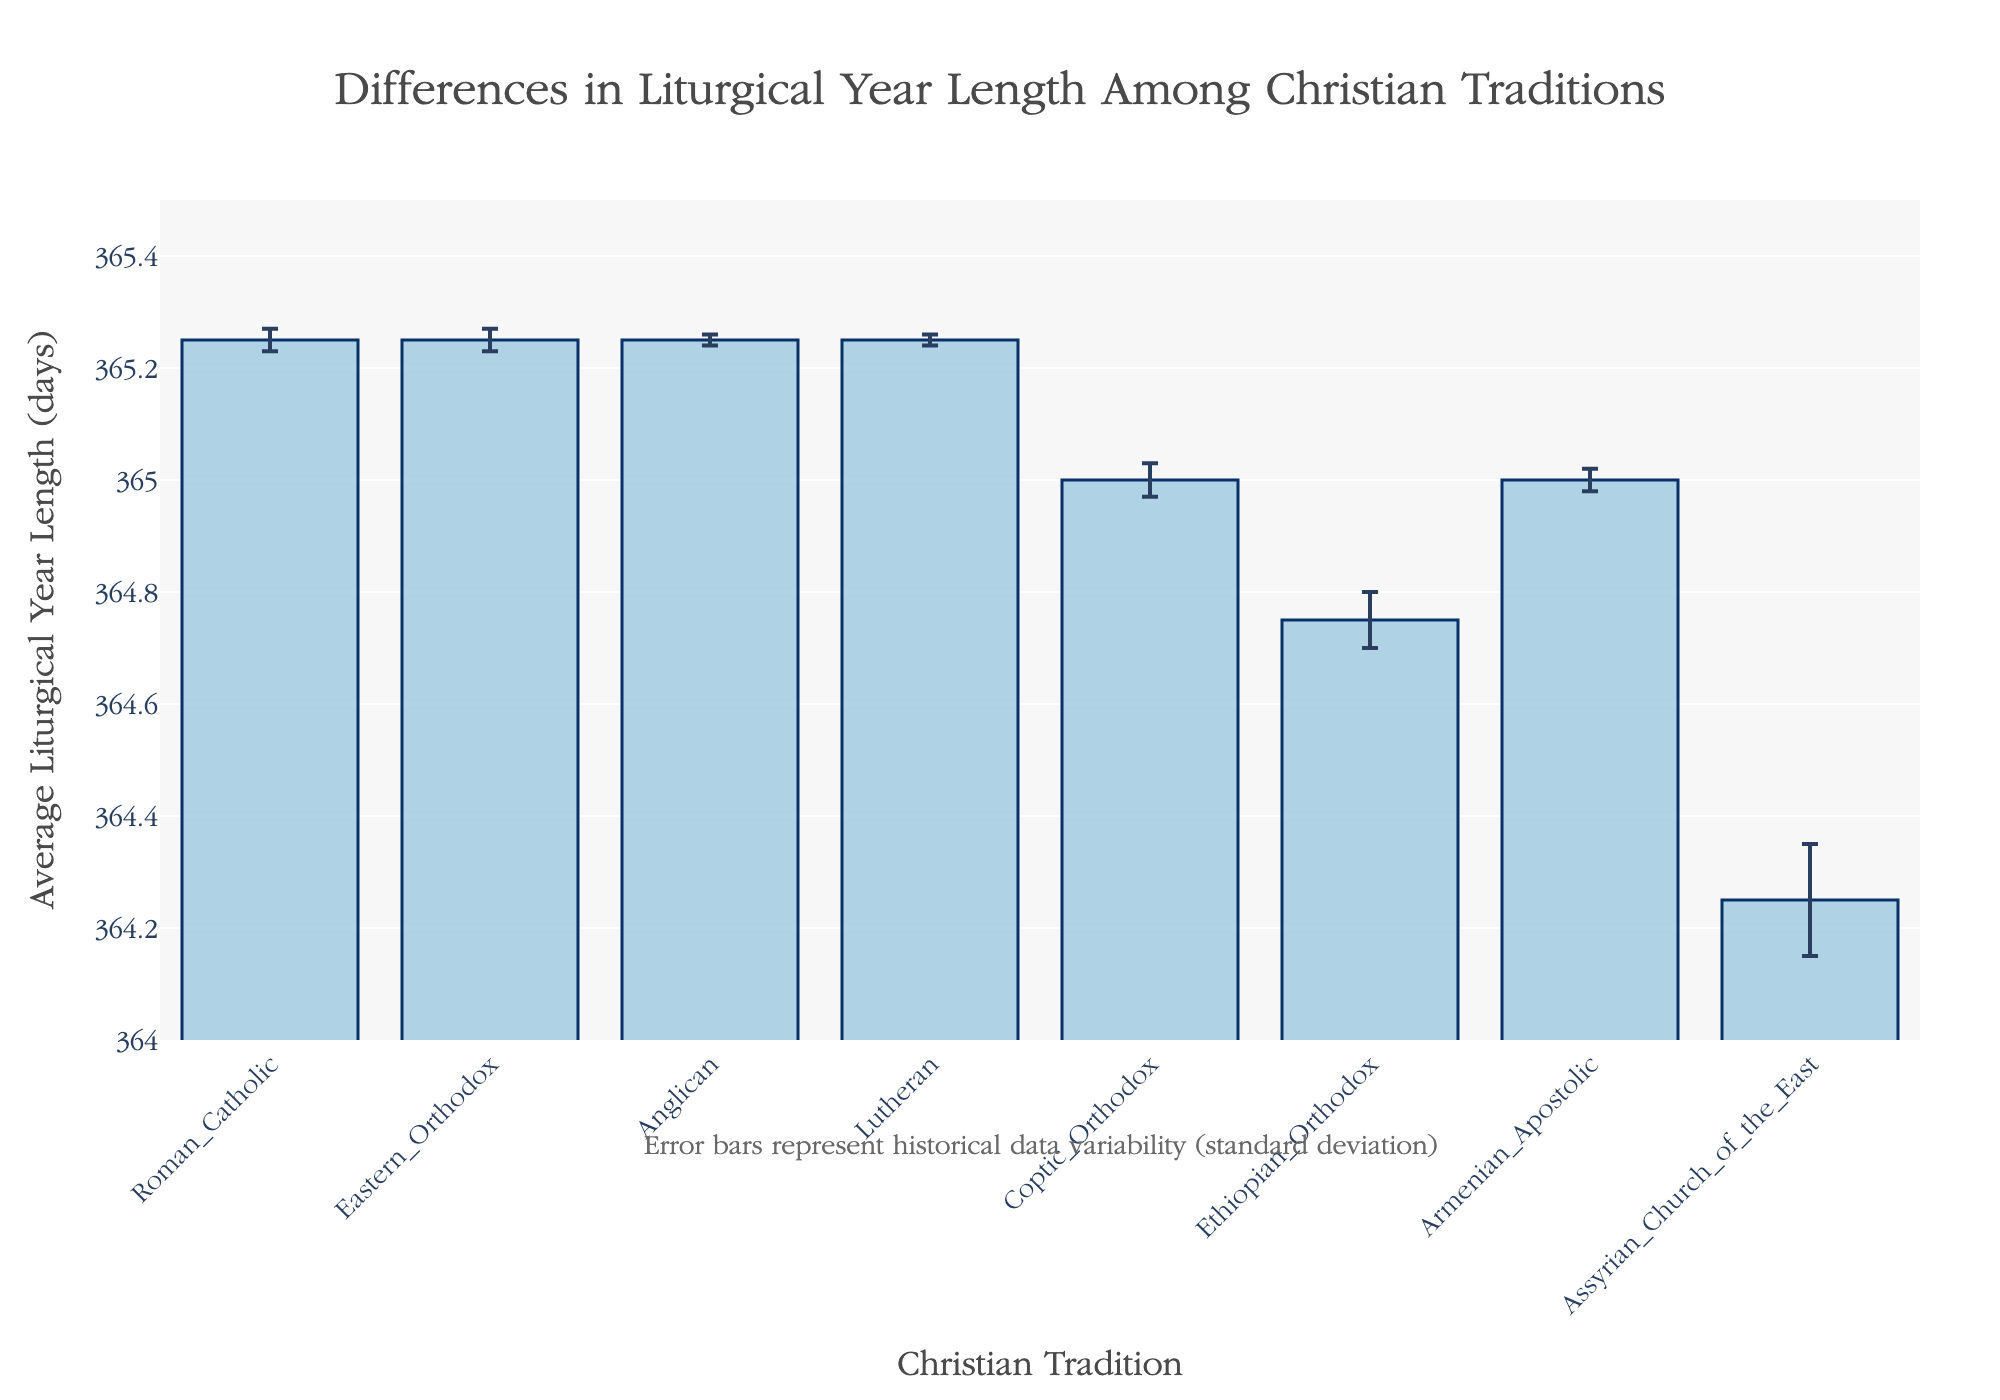What is the average length of the liturgical year for the Roman Catholic tradition? The figure shows the average liturgical year lengths on the y-axis, and the Roman Catholic tradition is one of the values on the x-axis. By locating Roman Catholic on the x-axis and checking the corresponding bar, we see 365.25 days.
Answer: 365.25 days Which tradition has the greatest variability in the length of its liturgical year? The variability is represented by the size of the error bars. The figure shows that the Assyrian Church of the East has the largest error bar, indicating the highest standard deviation.
Answer: Assyrian Church of the East How does the average liturgical year length of the Coptic Orthodox Church compare to the Roman Catholic Church? The Coptic Orthodox Church has an average liturgical year length of 365.00 days, while the Roman Catholic Church has an average of 365.25 days. The Roman Catholic year is 0.25 days longer.
Answer: Roman Catholic: 0.25 days longer What is the standard deviation in the liturgical year length for the Ethiopian Orthodox tradition? Standard deviation is indicated by the error bars. Following the Ethiopian Orthodox on the x-axis and checking the corresponding error bar value, we see it is 0.05 days.
Answer: 0.05 days Is the average liturgical year length of the Anglican tradition greater than 365 days? To answer this, we need to check whether the average point on the y-axis for the Anglican tradition exceeds 365 days. It is 365.25 days, which is greater than 365.
Answer: Yes Which traditions have the average liturgical year lengths less than 365 days? The figure shows that Ethiopian Orthodox (364.75 days) and Assyrian Church of the East (364.25 days) have average year lengths below 365 days.
Answer: Ethiopian Orthodox and Assyrian Church of the East How many traditions have an average liturgical year length exactly equal to 365.00 days? Checking the figure, we see that both Coptic Orthodox and Armenian Apostolic each have average liturgical year lengths of exactly 365.00 days.
Answer: 2 traditions Between Eastern Orthodox and Coptic Orthodox traditions, which has a smaller variability in liturgical year length? Variability is measured by the size of the error bars. The figure shows that Coptic Orthodox has a standard deviation of 0.03, whereas Eastern Orthodox has 0.02. Therefore, the Eastern Orthodox Church has smaller variability.
Answer: Eastern Orthodox What is the combined average liturgical year length of Anglican and Lutheran traditions? The figure shows that both Anglican and Lutheran churches have average year lengths of 365.25 days. Adding these together gives a combined average of 365.25 + 365.25 = 730.5 days.
Answer: 730.5 days What is the median average liturgical year length among all traditions shown? To find the median, we list the average lengths and find the middle value. The lengths are 364.25, 364.75, 365.00, 365.00, 365.25, 365.25, 365.25, 365.25. The median is the average of the 4th and 5th values, both of which are in the middle range of the sorted list (365.00 and 365.25). Thus, (365.00 + 365.25)/2 = 365.125.
Answer: 365.125 days 